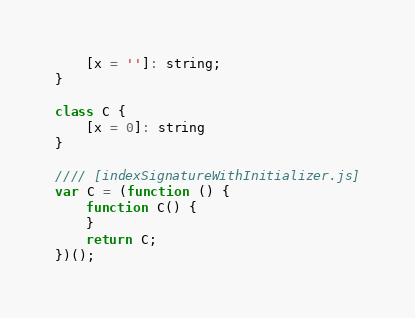Convert code to text. <code><loc_0><loc_0><loc_500><loc_500><_JavaScript_>    [x = '']: string;
}

class C {
    [x = 0]: string
}

//// [indexSignatureWithInitializer.js]
var C = (function () {
    function C() {
    }
    return C;
})();
</code> 